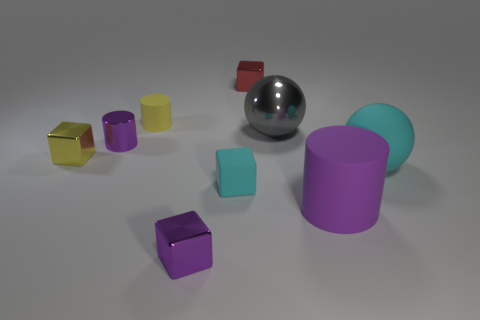There is a small matte cylinder that is behind the gray sphere; is there a purple object behind it?
Make the answer very short. No. How many cylinders are either tiny green rubber objects or yellow things?
Offer a terse response. 1. What is the size of the matte cylinder in front of the cube to the left of the tiny purple thing that is in front of the yellow metal thing?
Your answer should be very brief. Large. Are there any gray spheres behind the big shiny sphere?
Offer a very short reply. No. There is a object that is the same color as the matte cube; what is its shape?
Provide a short and direct response. Sphere. How many objects are purple shiny things behind the yellow metal block or tiny things?
Offer a very short reply. 6. What size is the purple cylinder that is made of the same material as the small red object?
Offer a very short reply. Small. There is a purple block; is its size the same as the purple cylinder that is right of the tiny purple cylinder?
Offer a terse response. No. What color is the tiny metal cube that is both left of the small cyan rubber object and behind the large purple cylinder?
Provide a succinct answer. Yellow. What number of things are either cubes that are in front of the large gray shiny sphere or purple cylinders on the left side of the purple matte object?
Ensure brevity in your answer.  4. 